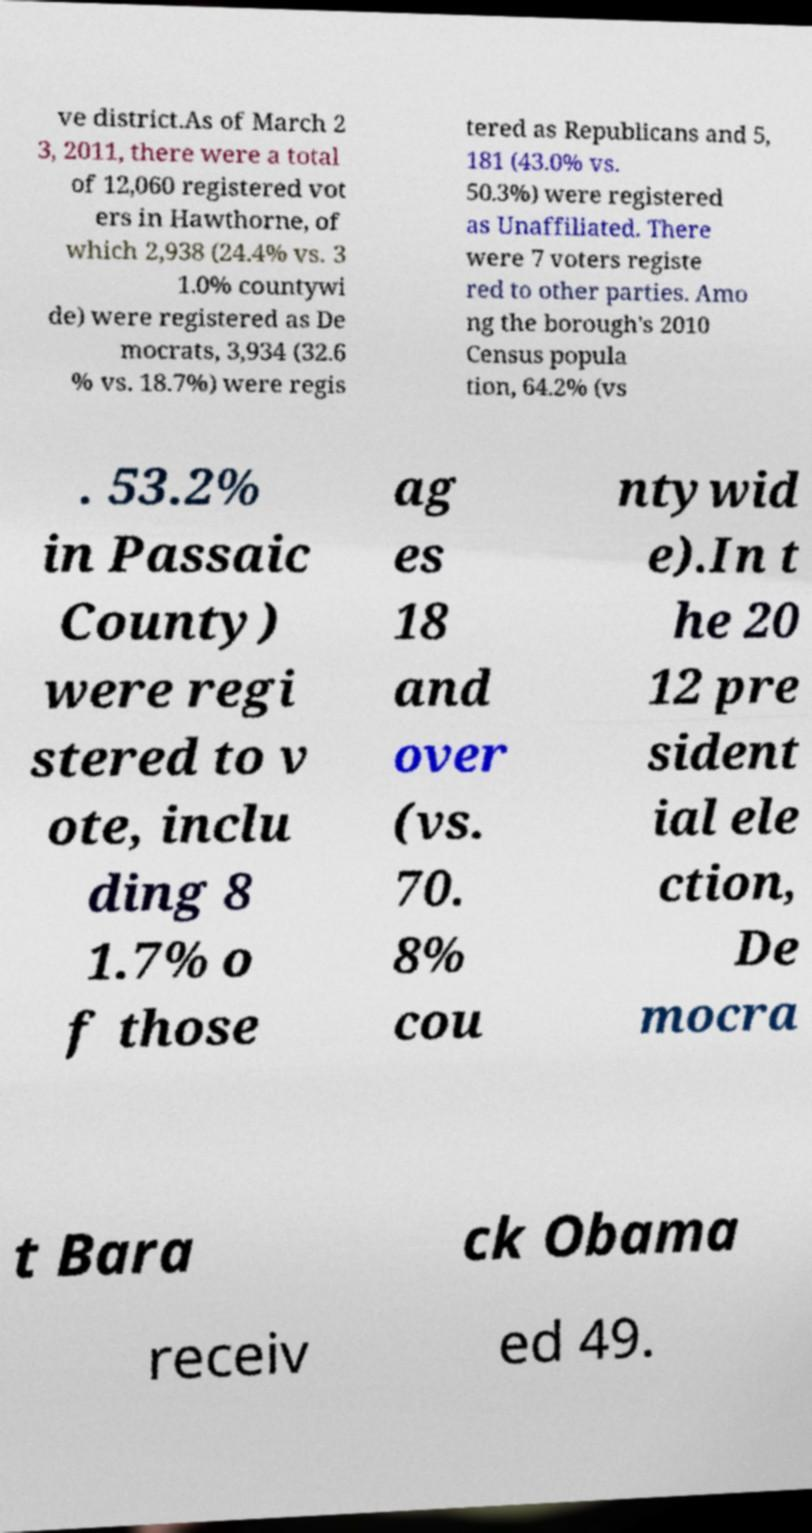There's text embedded in this image that I need extracted. Can you transcribe it verbatim? ve district.As of March 2 3, 2011, there were a total of 12,060 registered vot ers in Hawthorne, of which 2,938 (24.4% vs. 3 1.0% countywi de) were registered as De mocrats, 3,934 (32.6 % vs. 18.7%) were regis tered as Republicans and 5, 181 (43.0% vs. 50.3%) were registered as Unaffiliated. There were 7 voters registe red to other parties. Amo ng the borough's 2010 Census popula tion, 64.2% (vs . 53.2% in Passaic County) were regi stered to v ote, inclu ding 8 1.7% o f those ag es 18 and over (vs. 70. 8% cou ntywid e).In t he 20 12 pre sident ial ele ction, De mocra t Bara ck Obama receiv ed 49. 